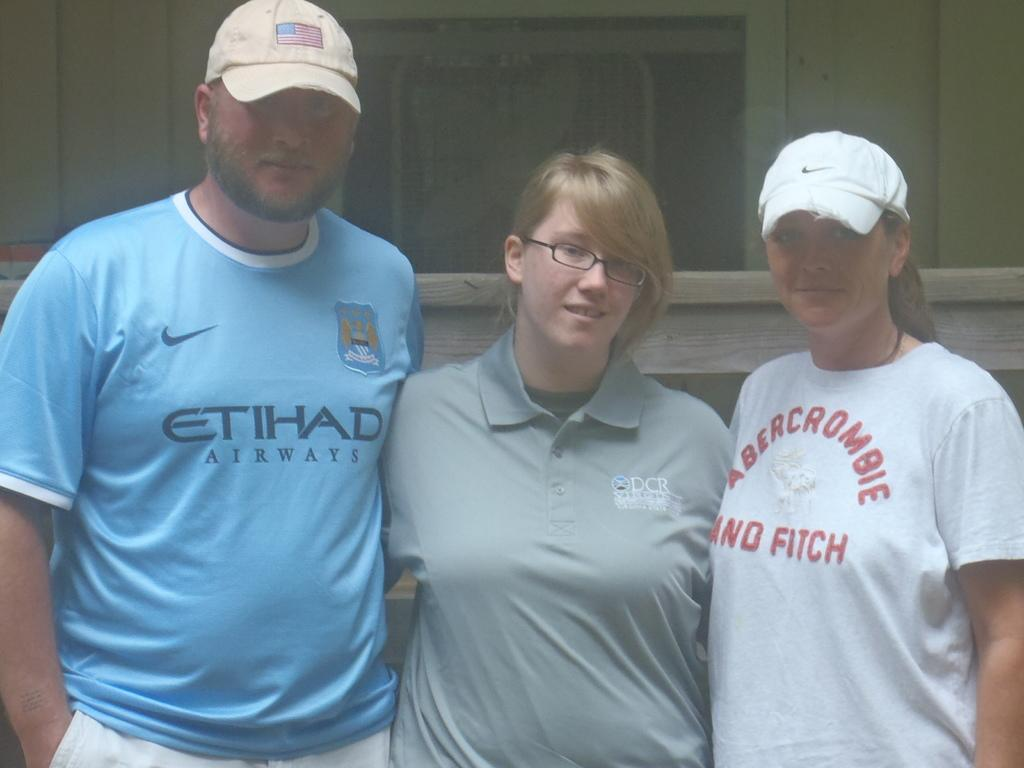Provide a one-sentence caption for the provided image. Three people are standing near each other and each have on t shirts that state a brand name like Abercrombie and Fitch and Etihad Airways. 